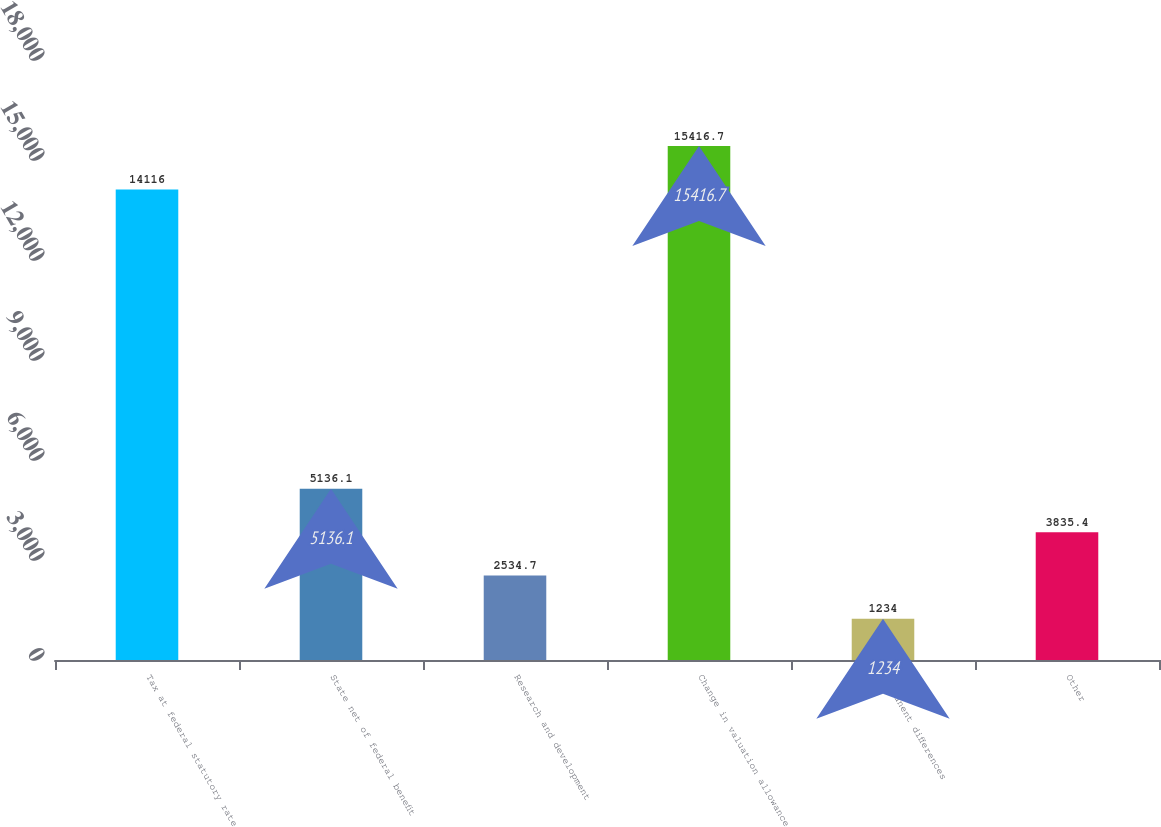Convert chart. <chart><loc_0><loc_0><loc_500><loc_500><bar_chart><fcel>Tax at federal statutory rate<fcel>State net of federal benefit<fcel>Research and development<fcel>Change in valuation allowance<fcel>Permanent differences<fcel>Other<nl><fcel>14116<fcel>5136.1<fcel>2534.7<fcel>15416.7<fcel>1234<fcel>3835.4<nl></chart> 